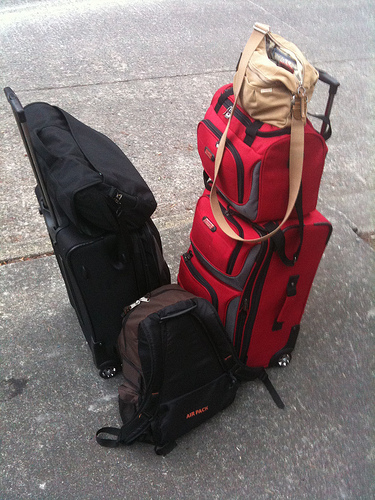Please provide a short description for this region: [0.67, 0.55, 0.72, 0.66]. This section reveals a red and black handle, sturdy looking and attached to one of the main luggage items, hinting at the luggage’s heavy-duty capability. 